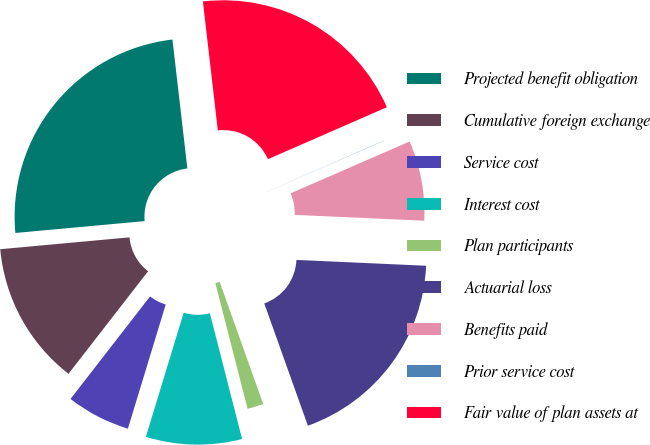Convert chart to OTSL. <chart><loc_0><loc_0><loc_500><loc_500><pie_chart><fcel>Projected benefit obligation<fcel>Cumulative foreign exchange<fcel>Service cost<fcel>Interest cost<fcel>Plan participants<fcel>Actuarial loss<fcel>Benefits paid<fcel>Prior service cost<fcel>Fair value of plan assets at<nl><fcel>24.62%<fcel>13.04%<fcel>5.8%<fcel>8.7%<fcel>1.46%<fcel>18.83%<fcel>7.25%<fcel>0.02%<fcel>20.28%<nl></chart> 